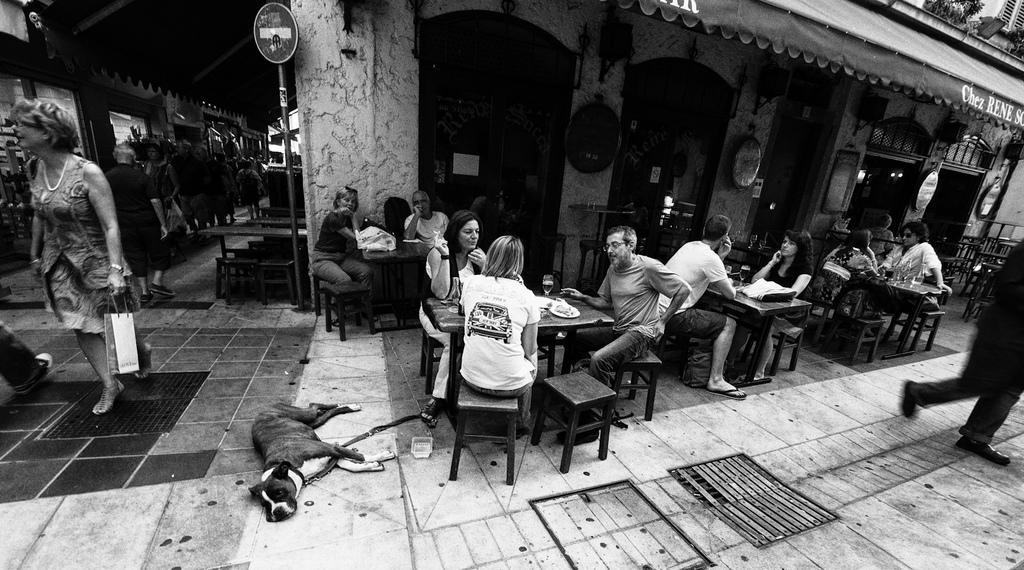Can you describe this image briefly? In this Picture shows a outside view of restaurant in which a group a people are sitting having four tables. In which first table by two women are sitting. On the second table a woman wearing white t- shirt and boy beside him, having a glass of beer and some food stuff. On another table a couple can be seen with bag on the table. And some hanging mirror can be seen on the wall and foldable roof top, caution board and a woman passing with bag. And dog lying on the ground. 